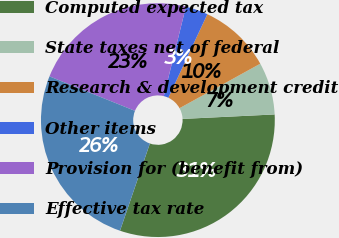Convert chart. <chart><loc_0><loc_0><loc_500><loc_500><pie_chart><fcel>Computed expected tax<fcel>State taxes net of federal<fcel>Research & development credit<fcel>Other items<fcel>Provision for (benefit from)<fcel>Effective tax rate<nl><fcel>31.02%<fcel>7.24%<fcel>10.03%<fcel>3.1%<fcel>22.75%<fcel>25.85%<nl></chart> 